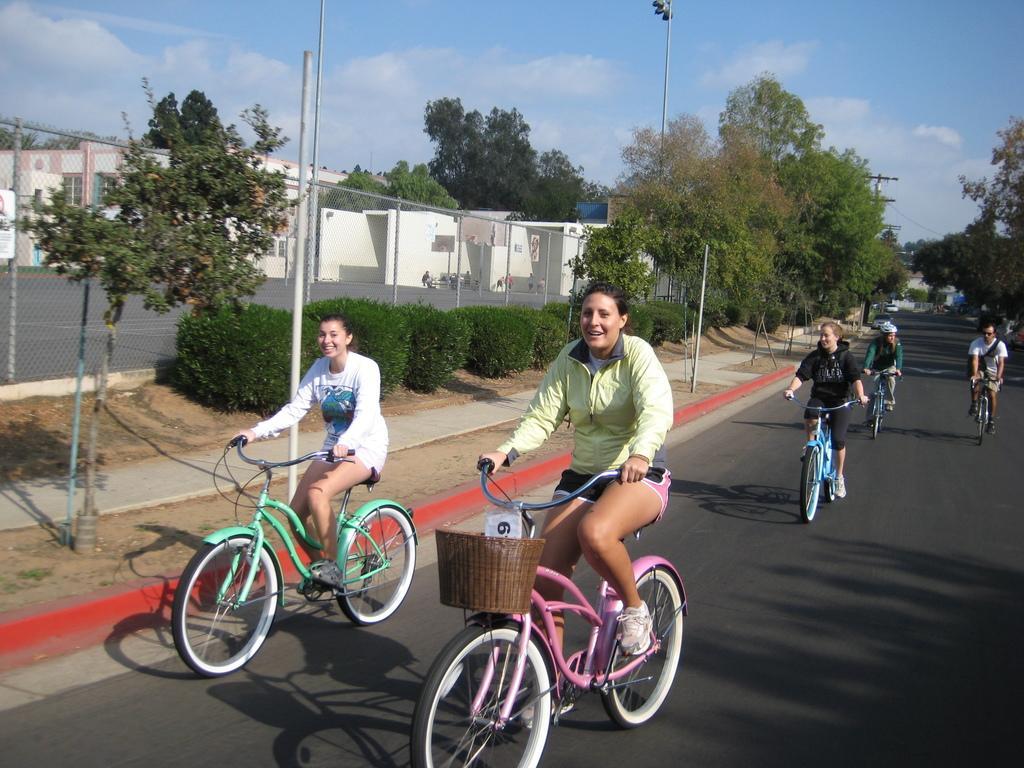How would you summarize this image in a sentence or two? In the image there are few girls riding bicycles on the road with trees on either side of it, on the left side it seems to be a basket ball court and above its sky with clouds. 